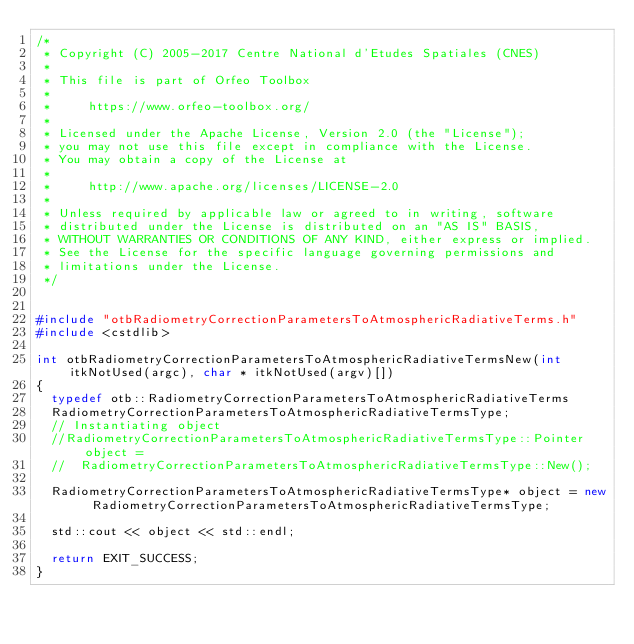<code> <loc_0><loc_0><loc_500><loc_500><_C++_>/*
 * Copyright (C) 2005-2017 Centre National d'Etudes Spatiales (CNES)
 *
 * This file is part of Orfeo Toolbox
 *
 *     https://www.orfeo-toolbox.org/
 *
 * Licensed under the Apache License, Version 2.0 (the "License");
 * you may not use this file except in compliance with the License.
 * You may obtain a copy of the License at
 *
 *     http://www.apache.org/licenses/LICENSE-2.0
 *
 * Unless required by applicable law or agreed to in writing, software
 * distributed under the License is distributed on an "AS IS" BASIS,
 * WITHOUT WARRANTIES OR CONDITIONS OF ANY KIND, either express or implied.
 * See the License for the specific language governing permissions and
 * limitations under the License.
 */


#include "otbRadiometryCorrectionParametersToAtmosphericRadiativeTerms.h"
#include <cstdlib>

int otbRadiometryCorrectionParametersToAtmosphericRadiativeTermsNew(int itkNotUsed(argc), char * itkNotUsed(argv)[])
{
  typedef otb::RadiometryCorrectionParametersToAtmosphericRadiativeTerms
  RadiometryCorrectionParametersToAtmosphericRadiativeTermsType;
  // Instantiating object
  //RadiometryCorrectionParametersToAtmosphericRadiativeTermsType::Pointer object =
  //  RadiometryCorrectionParametersToAtmosphericRadiativeTermsType::New();

  RadiometryCorrectionParametersToAtmosphericRadiativeTermsType* object = new RadiometryCorrectionParametersToAtmosphericRadiativeTermsType;

  std::cout << object << std::endl;

  return EXIT_SUCCESS;
}
</code> 